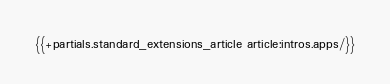Convert code to text. <code><loc_0><loc_0><loc_500><loc_500><_HTML_>{{+partials.standard_extensions_article article:intros.apps/}}
</code> 